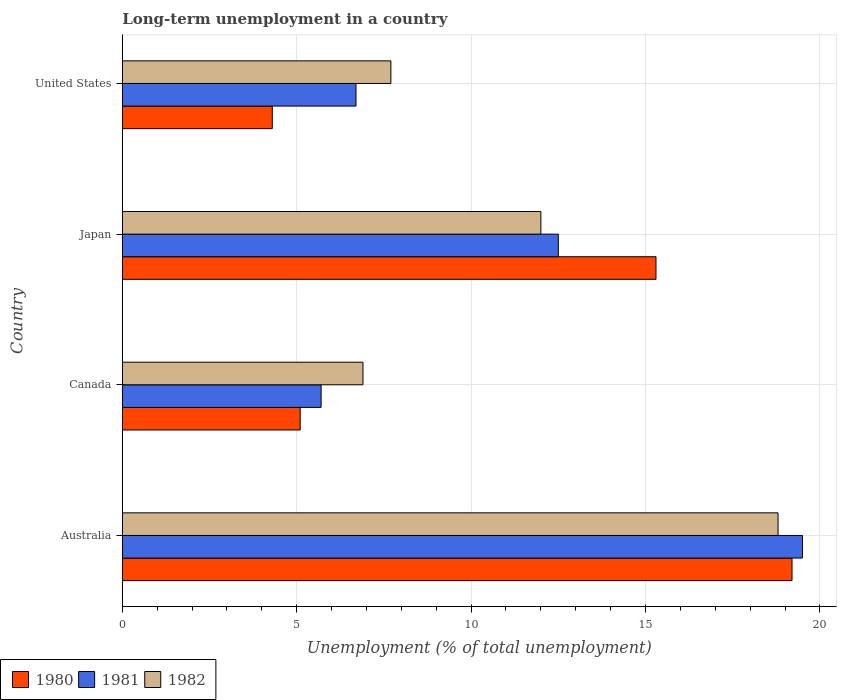How many groups of bars are there?
Offer a very short reply. 4. How many bars are there on the 1st tick from the bottom?
Make the answer very short. 3. What is the label of the 4th group of bars from the top?
Your answer should be compact. Australia. What is the percentage of long-term unemployed population in 1980 in Australia?
Provide a short and direct response. 19.2. Across all countries, what is the maximum percentage of long-term unemployed population in 1980?
Your answer should be very brief. 19.2. Across all countries, what is the minimum percentage of long-term unemployed population in 1981?
Ensure brevity in your answer.  5.7. In which country was the percentage of long-term unemployed population in 1980 maximum?
Offer a very short reply. Australia. What is the total percentage of long-term unemployed population in 1981 in the graph?
Your answer should be very brief. 44.4. What is the difference between the percentage of long-term unemployed population in 1982 in Australia and that in Canada?
Your answer should be very brief. 11.9. What is the difference between the percentage of long-term unemployed population in 1982 in United States and the percentage of long-term unemployed population in 1980 in Australia?
Your response must be concise. -11.5. What is the average percentage of long-term unemployed population in 1980 per country?
Provide a succinct answer. 10.98. In how many countries, is the percentage of long-term unemployed population in 1982 greater than 2 %?
Your answer should be compact. 4. What is the ratio of the percentage of long-term unemployed population in 1981 in Canada to that in United States?
Provide a short and direct response. 0.85. What is the difference between the highest and the second highest percentage of long-term unemployed population in 1980?
Provide a short and direct response. 3.9. What is the difference between the highest and the lowest percentage of long-term unemployed population in 1981?
Keep it short and to the point. 13.8. Is the sum of the percentage of long-term unemployed population in 1980 in Australia and United States greater than the maximum percentage of long-term unemployed population in 1982 across all countries?
Make the answer very short. Yes. What does the 3rd bar from the top in Japan represents?
Your answer should be compact. 1980. What does the 1st bar from the bottom in Australia represents?
Provide a short and direct response. 1980. How many countries are there in the graph?
Your response must be concise. 4. Are the values on the major ticks of X-axis written in scientific E-notation?
Offer a very short reply. No. Does the graph contain any zero values?
Give a very brief answer. No. What is the title of the graph?
Your answer should be compact. Long-term unemployment in a country. What is the label or title of the X-axis?
Make the answer very short. Unemployment (% of total unemployment). What is the label or title of the Y-axis?
Make the answer very short. Country. What is the Unemployment (% of total unemployment) of 1980 in Australia?
Your answer should be compact. 19.2. What is the Unemployment (% of total unemployment) in 1981 in Australia?
Your answer should be compact. 19.5. What is the Unemployment (% of total unemployment) in 1982 in Australia?
Ensure brevity in your answer.  18.8. What is the Unemployment (% of total unemployment) in 1980 in Canada?
Your answer should be very brief. 5.1. What is the Unemployment (% of total unemployment) of 1981 in Canada?
Offer a terse response. 5.7. What is the Unemployment (% of total unemployment) in 1982 in Canada?
Make the answer very short. 6.9. What is the Unemployment (% of total unemployment) in 1980 in Japan?
Offer a terse response. 15.3. What is the Unemployment (% of total unemployment) in 1980 in United States?
Offer a very short reply. 4.3. What is the Unemployment (% of total unemployment) of 1981 in United States?
Your response must be concise. 6.7. What is the Unemployment (% of total unemployment) of 1982 in United States?
Your answer should be very brief. 7.7. Across all countries, what is the maximum Unemployment (% of total unemployment) in 1980?
Offer a very short reply. 19.2. Across all countries, what is the maximum Unemployment (% of total unemployment) of 1982?
Your answer should be compact. 18.8. Across all countries, what is the minimum Unemployment (% of total unemployment) of 1980?
Your answer should be compact. 4.3. Across all countries, what is the minimum Unemployment (% of total unemployment) of 1981?
Your answer should be very brief. 5.7. Across all countries, what is the minimum Unemployment (% of total unemployment) in 1982?
Offer a terse response. 6.9. What is the total Unemployment (% of total unemployment) of 1980 in the graph?
Provide a short and direct response. 43.9. What is the total Unemployment (% of total unemployment) of 1981 in the graph?
Ensure brevity in your answer.  44.4. What is the total Unemployment (% of total unemployment) in 1982 in the graph?
Ensure brevity in your answer.  45.4. What is the difference between the Unemployment (% of total unemployment) in 1982 in Australia and that in Japan?
Give a very brief answer. 6.8. What is the difference between the Unemployment (% of total unemployment) of 1980 in Australia and that in United States?
Your answer should be compact. 14.9. What is the difference between the Unemployment (% of total unemployment) in 1981 in Australia and that in United States?
Provide a short and direct response. 12.8. What is the difference between the Unemployment (% of total unemployment) in 1981 in Canada and that in Japan?
Your answer should be compact. -6.8. What is the difference between the Unemployment (% of total unemployment) of 1980 in Canada and that in United States?
Ensure brevity in your answer.  0.8. What is the difference between the Unemployment (% of total unemployment) of 1981 in Canada and that in United States?
Provide a succinct answer. -1. What is the difference between the Unemployment (% of total unemployment) of 1981 in Japan and that in United States?
Provide a short and direct response. 5.8. What is the difference between the Unemployment (% of total unemployment) of 1982 in Japan and that in United States?
Ensure brevity in your answer.  4.3. What is the difference between the Unemployment (% of total unemployment) in 1980 in Australia and the Unemployment (% of total unemployment) in 1982 in Canada?
Offer a very short reply. 12.3. What is the difference between the Unemployment (% of total unemployment) in 1981 in Australia and the Unemployment (% of total unemployment) in 1982 in Japan?
Provide a short and direct response. 7.5. What is the difference between the Unemployment (% of total unemployment) in 1981 in Australia and the Unemployment (% of total unemployment) in 1982 in United States?
Provide a succinct answer. 11.8. What is the difference between the Unemployment (% of total unemployment) in 1980 in Canada and the Unemployment (% of total unemployment) in 1981 in Japan?
Make the answer very short. -7.4. What is the difference between the Unemployment (% of total unemployment) of 1981 in Canada and the Unemployment (% of total unemployment) of 1982 in Japan?
Keep it short and to the point. -6.3. What is the difference between the Unemployment (% of total unemployment) in 1981 in Canada and the Unemployment (% of total unemployment) in 1982 in United States?
Make the answer very short. -2. What is the difference between the Unemployment (% of total unemployment) of 1980 in Japan and the Unemployment (% of total unemployment) of 1981 in United States?
Ensure brevity in your answer.  8.6. What is the average Unemployment (% of total unemployment) of 1980 per country?
Offer a very short reply. 10.97. What is the average Unemployment (% of total unemployment) of 1981 per country?
Offer a very short reply. 11.1. What is the average Unemployment (% of total unemployment) in 1982 per country?
Offer a very short reply. 11.35. What is the difference between the Unemployment (% of total unemployment) in 1980 and Unemployment (% of total unemployment) in 1981 in Australia?
Your answer should be very brief. -0.3. What is the difference between the Unemployment (% of total unemployment) in 1980 and Unemployment (% of total unemployment) in 1982 in Australia?
Ensure brevity in your answer.  0.4. What is the difference between the Unemployment (% of total unemployment) of 1981 and Unemployment (% of total unemployment) of 1982 in Canada?
Your answer should be very brief. -1.2. What is the difference between the Unemployment (% of total unemployment) in 1980 and Unemployment (% of total unemployment) in 1982 in Japan?
Offer a terse response. 3.3. What is the difference between the Unemployment (% of total unemployment) in 1980 and Unemployment (% of total unemployment) in 1981 in United States?
Ensure brevity in your answer.  -2.4. What is the difference between the Unemployment (% of total unemployment) in 1981 and Unemployment (% of total unemployment) in 1982 in United States?
Your answer should be compact. -1. What is the ratio of the Unemployment (% of total unemployment) in 1980 in Australia to that in Canada?
Provide a succinct answer. 3.76. What is the ratio of the Unemployment (% of total unemployment) of 1981 in Australia to that in Canada?
Offer a very short reply. 3.42. What is the ratio of the Unemployment (% of total unemployment) in 1982 in Australia to that in Canada?
Offer a very short reply. 2.72. What is the ratio of the Unemployment (% of total unemployment) of 1980 in Australia to that in Japan?
Make the answer very short. 1.25. What is the ratio of the Unemployment (% of total unemployment) of 1981 in Australia to that in Japan?
Provide a succinct answer. 1.56. What is the ratio of the Unemployment (% of total unemployment) in 1982 in Australia to that in Japan?
Give a very brief answer. 1.57. What is the ratio of the Unemployment (% of total unemployment) in 1980 in Australia to that in United States?
Your answer should be very brief. 4.47. What is the ratio of the Unemployment (% of total unemployment) in 1981 in Australia to that in United States?
Offer a very short reply. 2.91. What is the ratio of the Unemployment (% of total unemployment) in 1982 in Australia to that in United States?
Keep it short and to the point. 2.44. What is the ratio of the Unemployment (% of total unemployment) of 1981 in Canada to that in Japan?
Ensure brevity in your answer.  0.46. What is the ratio of the Unemployment (% of total unemployment) of 1982 in Canada to that in Japan?
Make the answer very short. 0.57. What is the ratio of the Unemployment (% of total unemployment) of 1980 in Canada to that in United States?
Give a very brief answer. 1.19. What is the ratio of the Unemployment (% of total unemployment) of 1981 in Canada to that in United States?
Your response must be concise. 0.85. What is the ratio of the Unemployment (% of total unemployment) of 1982 in Canada to that in United States?
Offer a very short reply. 0.9. What is the ratio of the Unemployment (% of total unemployment) in 1980 in Japan to that in United States?
Offer a terse response. 3.56. What is the ratio of the Unemployment (% of total unemployment) of 1981 in Japan to that in United States?
Your response must be concise. 1.87. What is the ratio of the Unemployment (% of total unemployment) in 1982 in Japan to that in United States?
Offer a terse response. 1.56. What is the difference between the highest and the second highest Unemployment (% of total unemployment) in 1980?
Ensure brevity in your answer.  3.9. What is the difference between the highest and the second highest Unemployment (% of total unemployment) of 1981?
Give a very brief answer. 7. What is the difference between the highest and the lowest Unemployment (% of total unemployment) in 1980?
Your answer should be compact. 14.9. 